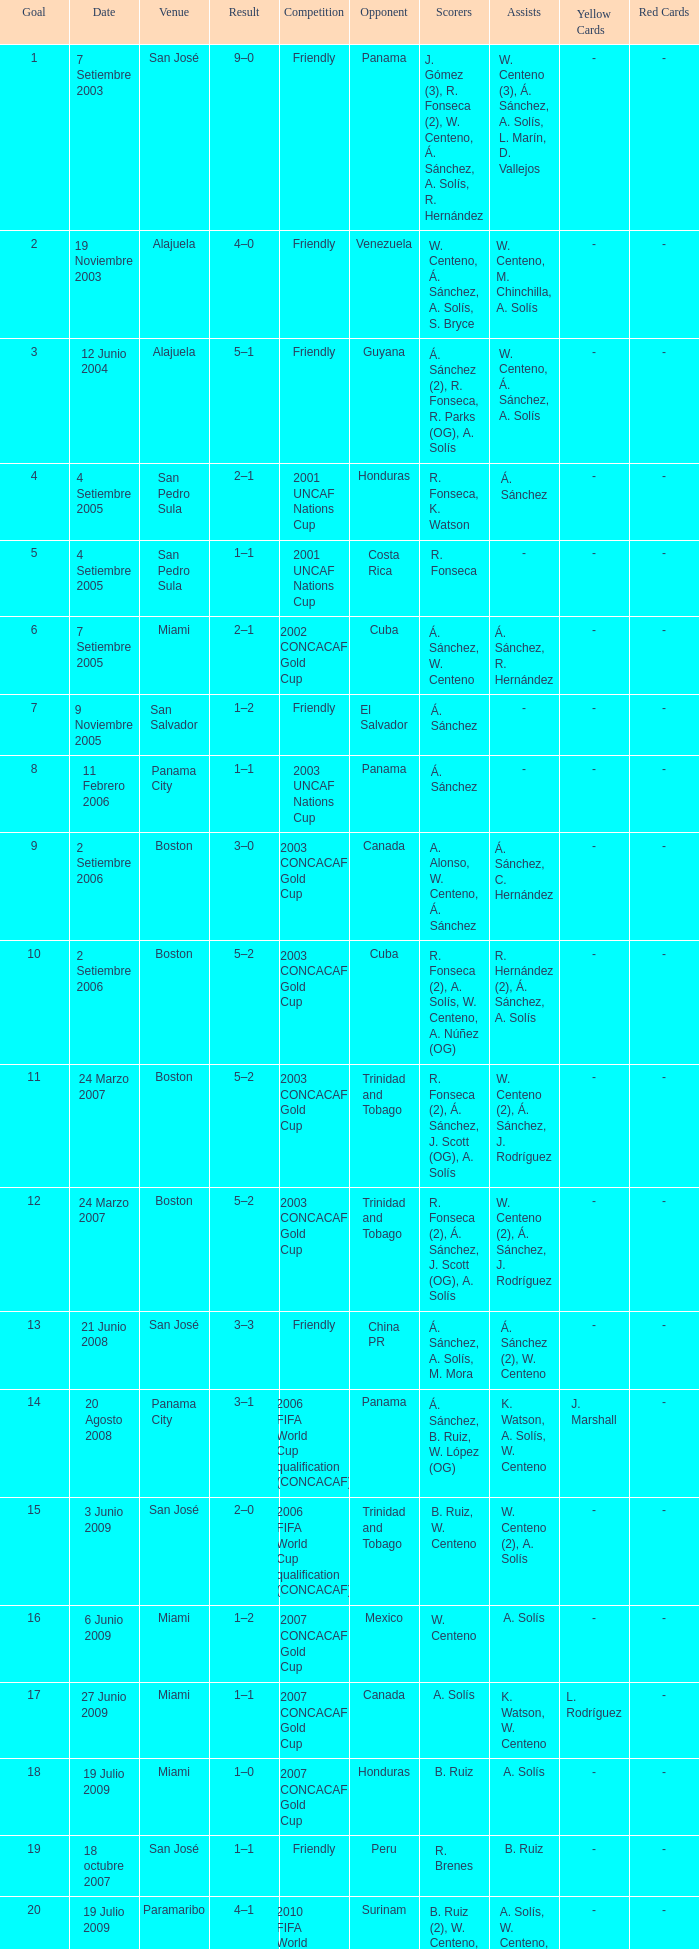Could you help me parse every detail presented in this table? {'header': ['Goal', 'Date', 'Venue', 'Result', 'Competition', 'Opponent', 'Scorers', 'Assists', 'Yellow Cards', 'Red Cards'], 'rows': [['1', '7 Setiembre 2003', 'San José', '9–0', 'Friendly', 'Panama', 'J. Gómez (3), R. Fonseca (2), W. Centeno, Á. Sánchez, A. Solís, R. Hernández', 'W. Centeno (3), Á. Sánchez, A. Solís, L. Marín, D. Vallejos', '-', '-'], ['2', '19 Noviembre 2003', 'Alajuela', '4–0', 'Friendly', 'Venezuela', 'W. Centeno, Á. Sánchez, A. Solís, S. Bryce', 'W. Centeno, M. Chinchilla, A. Solís', '-', '-'], ['3', '12 Junio 2004', 'Alajuela', '5–1', 'Friendly', 'Guyana', 'Á. Sánchez (2), R. Fonseca, R. Parks (OG), A. Solís', 'W. Centeno, Á. Sánchez, A. Solís', '-', '-'], ['4', '4 Setiembre 2005', 'San Pedro Sula', '2–1', '2001 UNCAF Nations Cup', 'Honduras', 'R. Fonseca, K. Watson', 'Á. Sánchez', '-', '-'], ['5', '4 Setiembre 2005', 'San Pedro Sula', '1–1', '2001 UNCAF Nations Cup', 'Costa Rica', 'R. Fonseca', '-', '-', '-'], ['6', '7 Setiembre 2005', 'Miami', '2–1', '2002 CONCACAF Gold Cup', 'Cuba', 'Á. Sánchez, W. Centeno', 'Á. Sánchez, R. Hernández', '-', '-'], ['7', '9 Noviembre 2005', 'San Salvador', '1–2', 'Friendly', 'El Salvador', 'Á. Sánchez', '-', '-', '-'], ['8', '11 Febrero 2006', 'Panama City', '1–1', '2003 UNCAF Nations Cup', 'Panama', 'Á. Sánchez', '-', '-', '-'], ['9', '2 Setiembre 2006', 'Boston', '3–0', '2003 CONCACAF Gold Cup', 'Canada', 'A. Alonso, W. Centeno, Á. Sánchez', 'Á. Sánchez, C. Hernández', '-', '-'], ['10', '2 Setiembre 2006', 'Boston', '5–2', '2003 CONCACAF Gold Cup', 'Cuba', 'R. Fonseca (2), A. Solís, W. Centeno, A. Núñez (OG)', 'R. Hernández (2), Á. Sánchez, A. Solís', '-', '-'], ['11', '24 Marzo 2007', 'Boston', '5–2', '2003 CONCACAF Gold Cup', 'Trinidad and Tobago', 'R. Fonseca (2), Á. Sánchez, J. Scott (OG), A. Solís', 'W. Centeno (2), Á. Sánchez, J. Rodríguez', '-', '-'], ['12', '24 Marzo 2007', 'Boston', '5–2', '2003 CONCACAF Gold Cup', 'Trinidad and Tobago', 'R. Fonseca (2), Á. Sánchez, J. Scott (OG), A. Solís', 'W. Centeno (2), Á. Sánchez, J. Rodríguez', '-', '-'], ['13', '21 Junio 2008', 'San José', '3–3', 'Friendly', 'China PR', 'Á. Sánchez, A. Solís, M. Mora', 'Á. Sánchez (2), W. Centeno', '-', '-'], ['14', '20 Agosto 2008', 'Panama City', '3–1', '2006 FIFA World Cup qualification (CONCACAF)', 'Panama', 'Á. Sánchez, B. Ruiz, W. López (OG)', 'K. Watson, A. Solís, W. Centeno', 'J. Marshall', '-'], ['15', '3 Junio 2009', 'San José', '2–0', '2006 FIFA World Cup qualification (CONCACAF)', 'Trinidad and Tobago', 'B. Ruiz, W. Centeno', 'W. Centeno (2), A. Solís', '-', '-'], ['16', '6 Junio 2009', 'Miami', '1–2', '2007 CONCACAF Gold Cup', 'Mexico', 'W. Centeno', 'A. Solís', '-', '-'], ['17', '27 Junio 2009', 'Miami', '1–1', '2007 CONCACAF Gold Cup', 'Canada', 'A. Solís', 'K. Watson, W. Centeno', 'L. Rodríguez', '-'], ['18', '19 Julio 2009', 'Miami', '1–0', '2007 CONCACAF Gold Cup', 'Honduras', 'B. Ruiz', 'A. Solís', '-', '-'], ['19', '18 octubre 2007', 'San José', '1–1', 'Friendly', 'Peru', 'R. Brenes', 'B. Ruiz', '-', '-'], ['20', '19 Julio 2009', 'Paramaribo', '4–1', '2010 FIFA World Cup qualification (CONCACAF)', 'Surinam', 'B. Ruiz (2), W. Centeno, A. Solís', 'A. Solís, W. Centeno, B. Ruiz', '-', '-'], ['21', '3 Junio 2009', 'San José', '1–0', '2010 FIFA World Cup qualification (CONCACAF)', 'El Salvador', 'A. Solís', 'M. Ureña, Á. Sánchez', '-', '-'], ['22', '6 Junio 2009', 'Florida', '2–2', '2009 CONCACAF Gold Cup', 'Canada', 'Á. Sánchez, B. Ruiz', 'J. Marshall, Á. Sánchez', '-', '-'], ['23', '27 Junio 2009', 'San José', '4–0', '2010 FIFA World Cup qualification (CONCACAF)', 'Trinidad and Tobago', 'Á. Sánchez (2), B. Ruiz, K. Watson', 'W. Centeno, M. Barrantes', '-', '-'], ['24', '19 Julio 2009', 'Montevideo', '1–1', '2010 FIFA World Cup qualification (CONCACAF)', 'Uruguay', 'Á. Sánchez', 'B. Ruiz', 'W. Centeno', '-']]} At the venue of panama city, on 11 Febrero 2006, how many goals were scored? 1.0. 